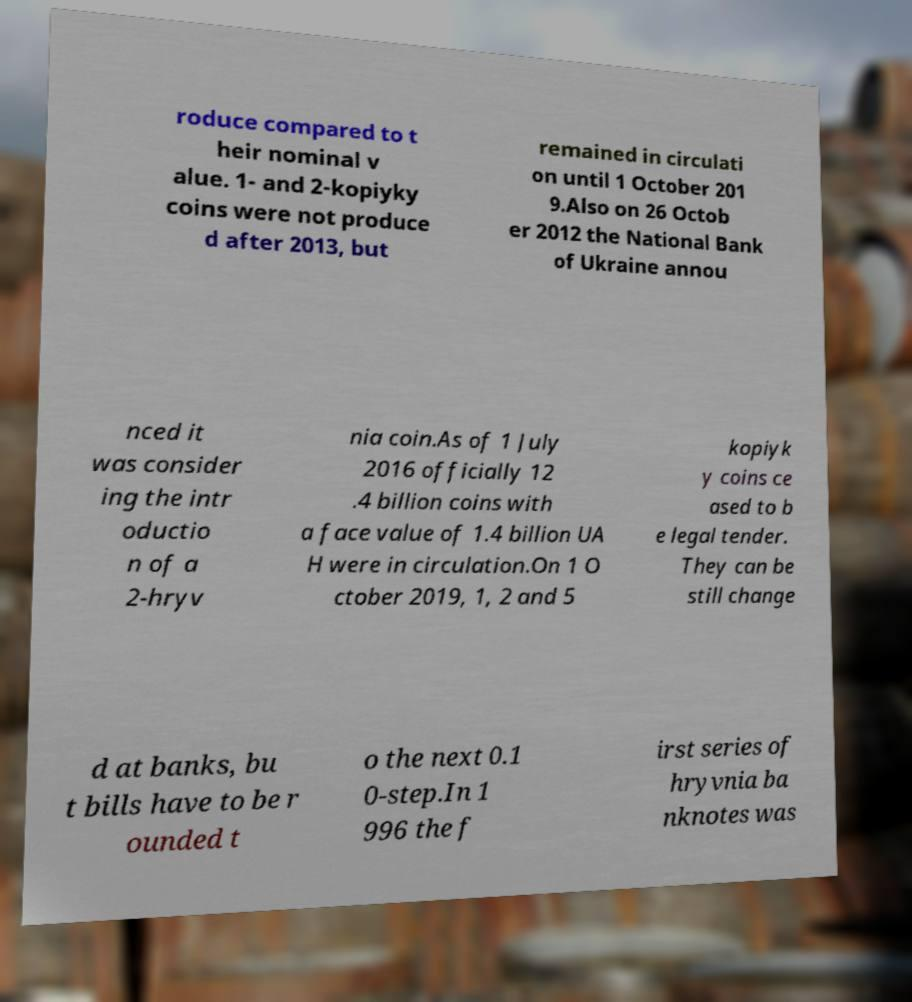Please identify and transcribe the text found in this image. roduce compared to t heir nominal v alue. 1- and 2-kopiyky coins were not produce d after 2013, but remained in circulati on until 1 October 201 9.Also on 26 Octob er 2012 the National Bank of Ukraine annou nced it was consider ing the intr oductio n of a 2-hryv nia coin.As of 1 July 2016 officially 12 .4 billion coins with a face value of 1.4 billion UA H were in circulation.On 1 O ctober 2019, 1, 2 and 5 kopiyk y coins ce ased to b e legal tender. They can be still change d at banks, bu t bills have to be r ounded t o the next 0.1 0-step.In 1 996 the f irst series of hryvnia ba nknotes was 